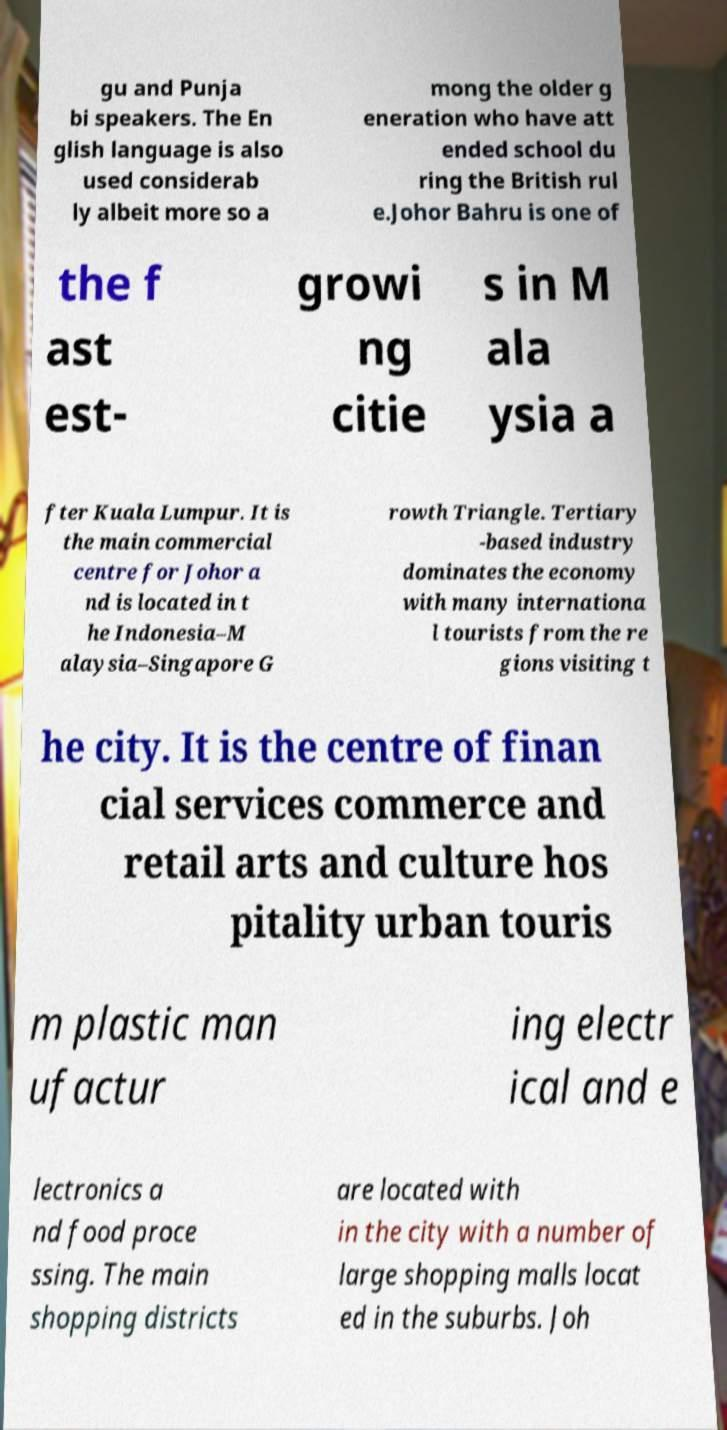Please identify and transcribe the text found in this image. gu and Punja bi speakers. The En glish language is also used considerab ly albeit more so a mong the older g eneration who have att ended school du ring the British rul e.Johor Bahru is one of the f ast est- growi ng citie s in M ala ysia a fter Kuala Lumpur. It is the main commercial centre for Johor a nd is located in t he Indonesia–M alaysia–Singapore G rowth Triangle. Tertiary -based industry dominates the economy with many internationa l tourists from the re gions visiting t he city. It is the centre of finan cial services commerce and retail arts and culture hos pitality urban touris m plastic man ufactur ing electr ical and e lectronics a nd food proce ssing. The main shopping districts are located with in the city with a number of large shopping malls locat ed in the suburbs. Joh 